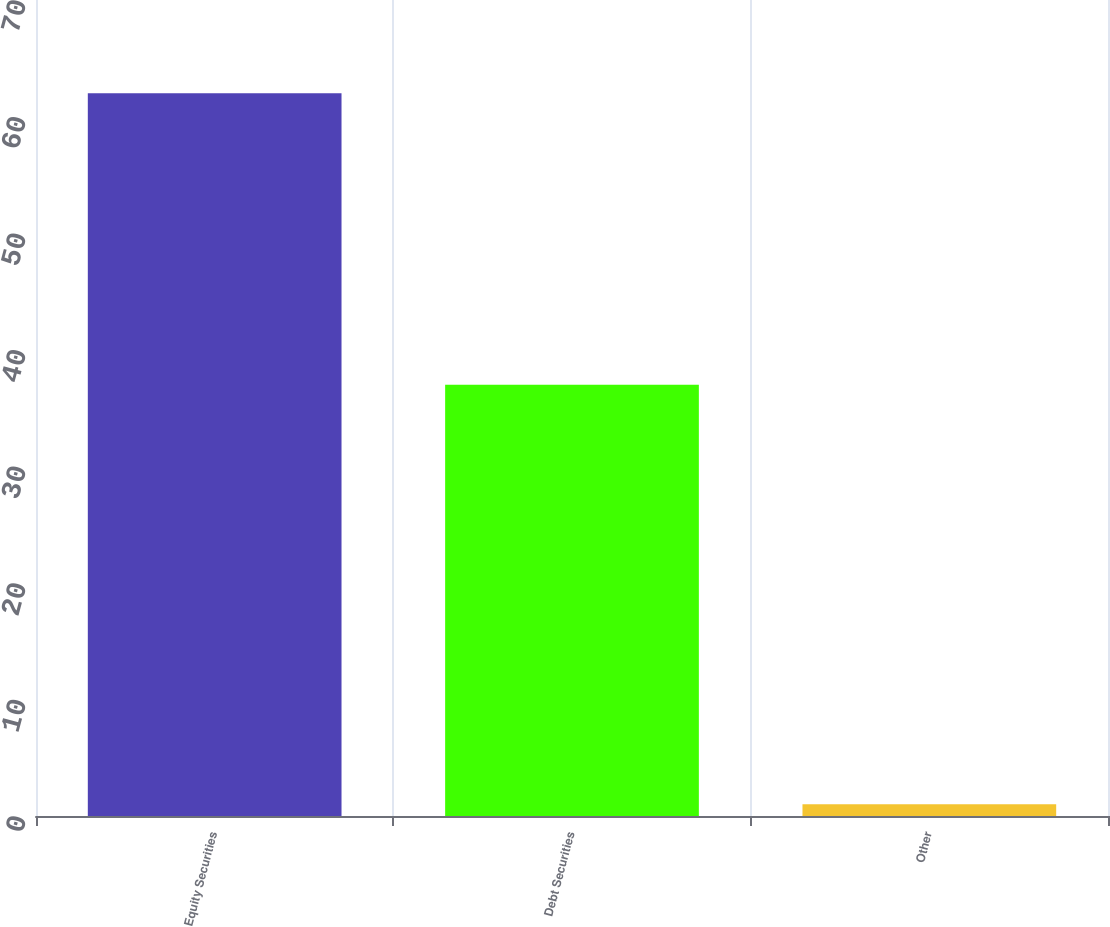<chart> <loc_0><loc_0><loc_500><loc_500><bar_chart><fcel>Equity Securities<fcel>Debt Securities<fcel>Other<nl><fcel>62<fcel>37<fcel>1<nl></chart> 